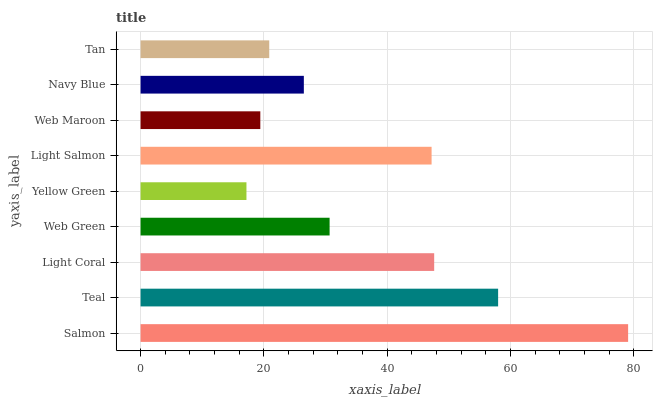Is Yellow Green the minimum?
Answer yes or no. Yes. Is Salmon the maximum?
Answer yes or no. Yes. Is Teal the minimum?
Answer yes or no. No. Is Teal the maximum?
Answer yes or no. No. Is Salmon greater than Teal?
Answer yes or no. Yes. Is Teal less than Salmon?
Answer yes or no. Yes. Is Teal greater than Salmon?
Answer yes or no. No. Is Salmon less than Teal?
Answer yes or no. No. Is Web Green the high median?
Answer yes or no. Yes. Is Web Green the low median?
Answer yes or no. Yes. Is Salmon the high median?
Answer yes or no. No. Is Light Coral the low median?
Answer yes or no. No. 